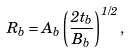Convert formula to latex. <formula><loc_0><loc_0><loc_500><loc_500>R _ { b } = A _ { b } \left ( \frac { 2 t _ { b } } { B _ { b } } \right ) ^ { 1 / 2 } ,</formula> 